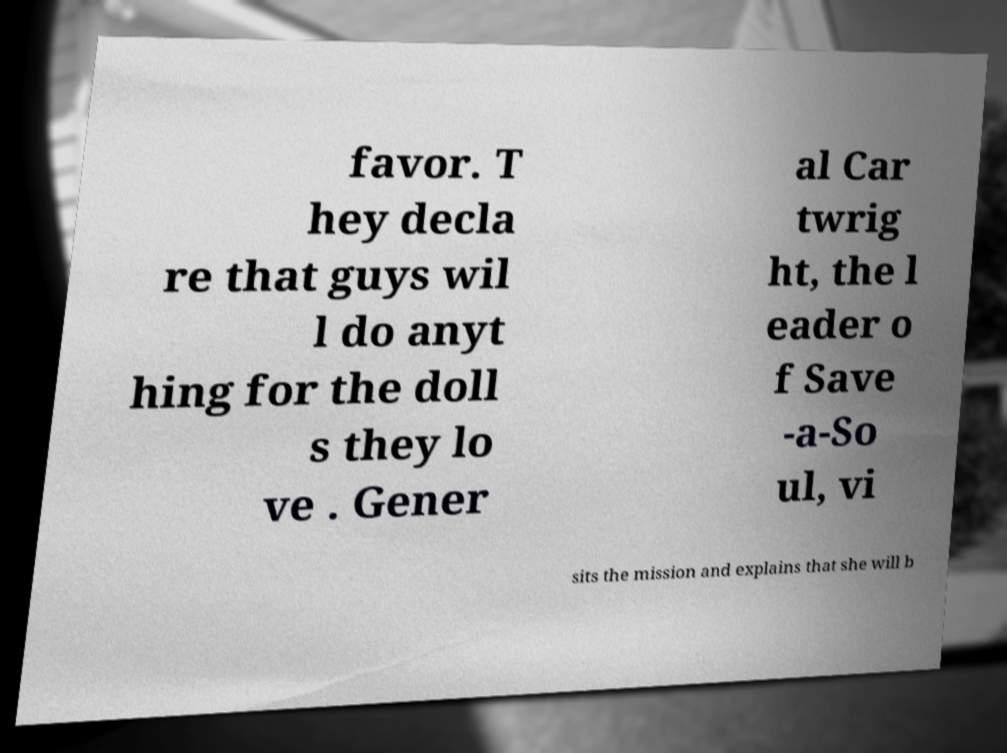What messages or text are displayed in this image? I need them in a readable, typed format. favor. T hey decla re that guys wil l do anyt hing for the doll s they lo ve . Gener al Car twrig ht, the l eader o f Save -a-So ul, vi sits the mission and explains that she will b 